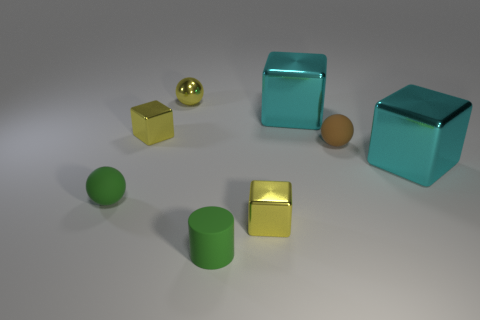Subtract all tiny brown balls. How many balls are left? 2 Add 1 tiny metallic blocks. How many objects exist? 9 Subtract all cylinders. How many objects are left? 7 Subtract all yellow spheres. How many spheres are left? 2 Subtract 0 blue cylinders. How many objects are left? 8 Subtract 1 cylinders. How many cylinders are left? 0 Subtract all brown cylinders. Subtract all yellow spheres. How many cylinders are left? 1 Subtract all yellow blocks. How many yellow balls are left? 1 Subtract all big gray things. Subtract all matte spheres. How many objects are left? 6 Add 5 yellow metal objects. How many yellow metal objects are left? 8 